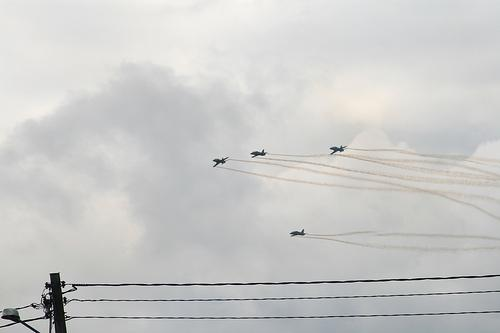Identify the type of vehicles present in the image and what is unique about them. The image features airplanes, specifically jets, flying in formation and releasing smoke, while doing stunts in the air. How many clouds are visible in the image, and how do they look? There are 5 clouds visible in the image, including white fluffy clouds, a grey-looking cloud, and a bright white cloud. What are the main objects in the image, and how are they interacting with one another? Planes are flying in the air, releasing smoke into the atmosphere near electrical lines, following each other in formation, and performing stunts. The sky is cloudy with grey and white clouds, and there are overhead power lines and a street lamp in the foreground. Analyze how the airplanes are interacting with their environment. The airplanes are interacting with their environment by flying near electrical lines, disrupting the calmness of the cloudy sky, and leaving trails of smoke behind them as they perform stunts. Count the number of significant objects in the image. There are a total of 9 significant objects in the image: 4 planes, electrical lines, power pole, street lamp, telephone lines, and clouds. What is the general quality of the image based on the information given? The image generally seems to be of good quality, with the objects clearly visible, including the planes, clouds, and electrical lines. Describe the weather and the sky condition in the image. It is a very cloudy day with grey sky and white fluffy clouds surrounding the planes flying and performing stunts in the air. What is the sentiment evoked by the image with all the elements in it? The image evokes a sense of excitement and awe as the planes perform stunts and release smoke in the air, against the backdrop of the grey sky and clouds. Based on the given information, what type of reasoning task can be deduced from the image? A complex reasoning task can be deduced from the image, as it involves analyzing the interactions between planes, clouds, and electrical lines, and understanding the planes' stunts and formation in the context of their environment. How many planes can be seen in the picture, and in what formation are they flying? There are four planes seen in the picture, flying together in a formation and performing stunts in the sky. Is there any object that is interacting with the electrical power pole? Yes, overhead power lines and a pea knob on the side of the power pole What can you tell about the color and appearance of the clouds in the sky? There are grey and bright white clouds, and some of them appear fluffy Can you see the plane's propellers? There is no mention of propellers on any of the planes in the given list of captions. Most of the captions refer to them as jets, which typically do not have propellers. Which part of the airplane is visible at the following coordinates: (210, 162)? Left wing on a flying airplane Which plane is closest to the ground? The plane lowest to the ground is the third one in the formation Do you notice the sun shining through the clouds? None of the provided captions mention the sun or any hint of sunlight coming through the clouds. Describe the electrical object present in the lower part of the image. An electrical power pole with overhead power lines and a mounted overhead light Is there a street lamp in the image? If yes, describe its position. Yes, there is a mounted overhead light towards the bottom left of the image What type of formation are the planes flying in? The leading plane is flying ahead, followed by the second, third, and fourth planes Are the jets flying towards or away from the camera? Jets flying away from the camera What are the jets doing in the sky? Performing stunts and releasing smoke Is that a flock of birds flying near the electrical wires? The captions explicitly mention planes and not birds. There are no captions mentioning birds in the image. Select the incorrect statement from these options: A) There is a group of four jets flying together; B) It is a sunny day with clear skies; C) There are overhead power lines in the image; D) A cloud in the image is described as looking grey and rather heavy. B) It is a sunny day with clear skies Describe the formation of the planes in the air. The planes are flying together in a formation, with one leading and the rest following Express the scene in a concise and creative manner. Jets dance gracefully in the cloudy sky, painting it with streaks of smoke, while the silent power lines stand witness below Select the correct description of the scene from the following options: A) planes flying on a sunny day; B) jets performing stunts in the sky and releasing smoke on a cloudy day; C) people gathering around an electrical power pole; D) a peaceful landscape with no airplanes in the sky. B) Jets performing stunts in the sky and releasing smoke on a cloudy day What is the weather like in the image? It is a cloudy day with a grey sky and white fluffy clouds Is there any sign of a storm approaching in the sky? Although the captions describe a grey sky with white fluffy clouds, there is no mention of an incoming storm or any hint of storm-related characteristics in the clouds or sky. What do the planes appear to be doing together in the sky? Jets are flying in formation, doing stunts, and releasing smoke Can you see the red portion on the wings of the planes? There is no mention of any color on the planes' wings or any part of the airplanes in the given captions. Identify the object in the following coordinates: (428, 152) Contrails in the sky How many planes can you see in this image? Four jets Describe the position of the smoke being released by the planes. The smoke is being released in the air, around and behind the planes Is the airplane in the middle of doing a loop? None of the captions mention a plane performing a loop or any similar stunt. What are the black lines running throughout the image? Black power lines 